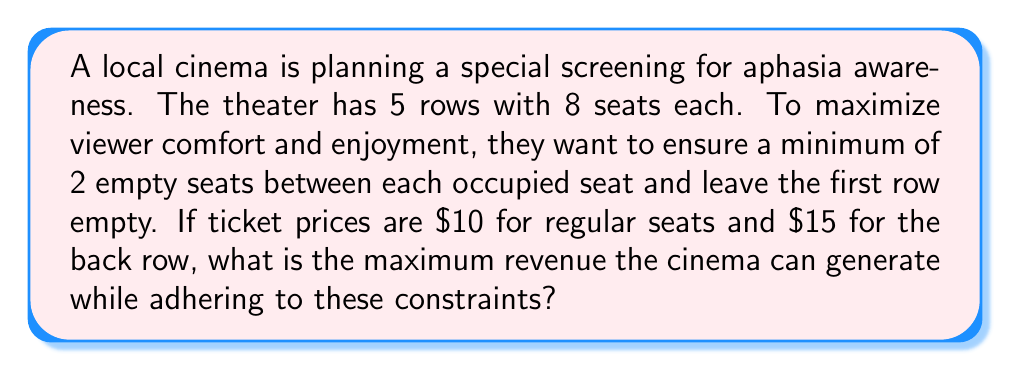Teach me how to tackle this problem. Let's approach this step-by-step using linear programming:

1) Define variables:
   Let $x_i$ represent the number of occupied seats in row $i$ (i = 2, 3, 4, 5)

2) Objective function:
   Maximize revenue: $Z = 10(x_2 + x_3 + x_4) + 15x_5$

3) Constraints:
   a) Number of seats per row: $x_i \leq 8$ for i = 2, 3, 4, 5
   b) Minimum 2 empty seats between occupied seats: $x_i \leq 3$ for i = 2, 3, 4, 5
   c) First row empty: No constraint needed as it's not in our variables
   d) Non-negativity: $x_i \geq 0$ for i = 2, 3, 4, 5

4) Linear Program:
   Maximize $Z = 10(x_2 + x_3 + x_4) + 15x_5$
   Subject to:
   $x_2, x_3, x_4, x_5 \leq 3$
   $x_2, x_3, x_4, x_5 \geq 0$

5) Solution:
   The optimal solution is to fill rows 2, 3, 4, and 5 with 3 people each.

6) Calculate maximum revenue:
   $Z = 10(3 + 3 + 3) + 15(3) = 90 + 45 = 135$

Therefore, the maximum revenue the cinema can generate is $135.
Answer: $135 